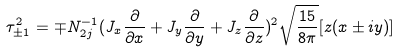<formula> <loc_0><loc_0><loc_500><loc_500>\tau _ { \pm 1 } ^ { 2 } = \mp N _ { 2 j } ^ { - 1 } ( J _ { x } \frac { \partial } { \partial x } + J _ { y } \frac { \partial } { \partial y } + J _ { z } \frac { \partial } { \partial z } ) ^ { 2 } \sqrt { \frac { 1 5 } { 8 \pi } } [ z ( x \pm i y ) ]</formula> 